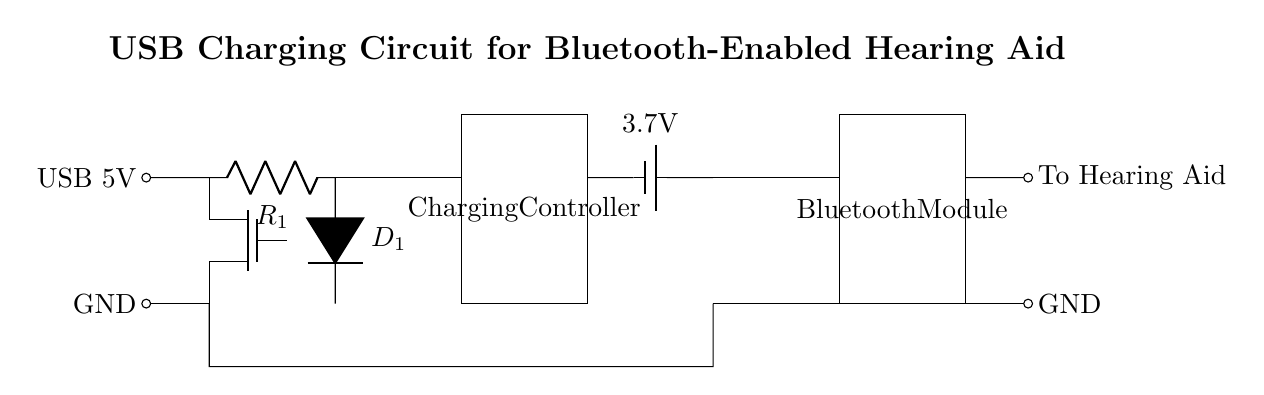What is the input voltage for this circuit? The circuit shows a USB connection which typically provides an input voltage of 5 volts. This is indicated as USB 5V in the diagram.
Answer: 5 volts What component is used to regulate the voltage? The component used to regulate the voltage is a Tnmos, which is a type of transistor typically used in low-voltage applications to manage power.
Answer: Tnmos What is the purpose of the charging controller? The charging controller manages the charging process for the battery, ensuring safe and efficient energy transfer. It can control the charging current and prevent overcharging.
Answer: Manage charging How many volts does the battery supply? The battery is labeled as providing a voltage of 3.7 volts, which indicates the potential difference available from the battery to the rest of the circuit.
Answer: 3.7 volts What component connects the battery to the Bluetooth module? The battery connects to the Bluetooth module through a direct line. There's no additional component specified between these two, allowing for efficient power delivery.
Answer: Direct line Which output goes to the hearing aid? The output going to the hearing aid is connected from the Bluetooth module, indicated as "To Hearing Aid" in the diagram, which shows that the module directly supplies it with audio signals.
Answer: To Hearing Aid What is the role of the diode in the circuit? The diode, indicated as D1, allows current to flow in one direction, preventing any backflow that could damage components in the circuit. This helps maintain the integrity of power delivery to the battery.
Answer: Prevent backflow 